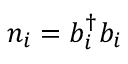<formula> <loc_0><loc_0><loc_500><loc_500>n _ { i } = b _ { i } ^ { \dag } b _ { i }</formula> 